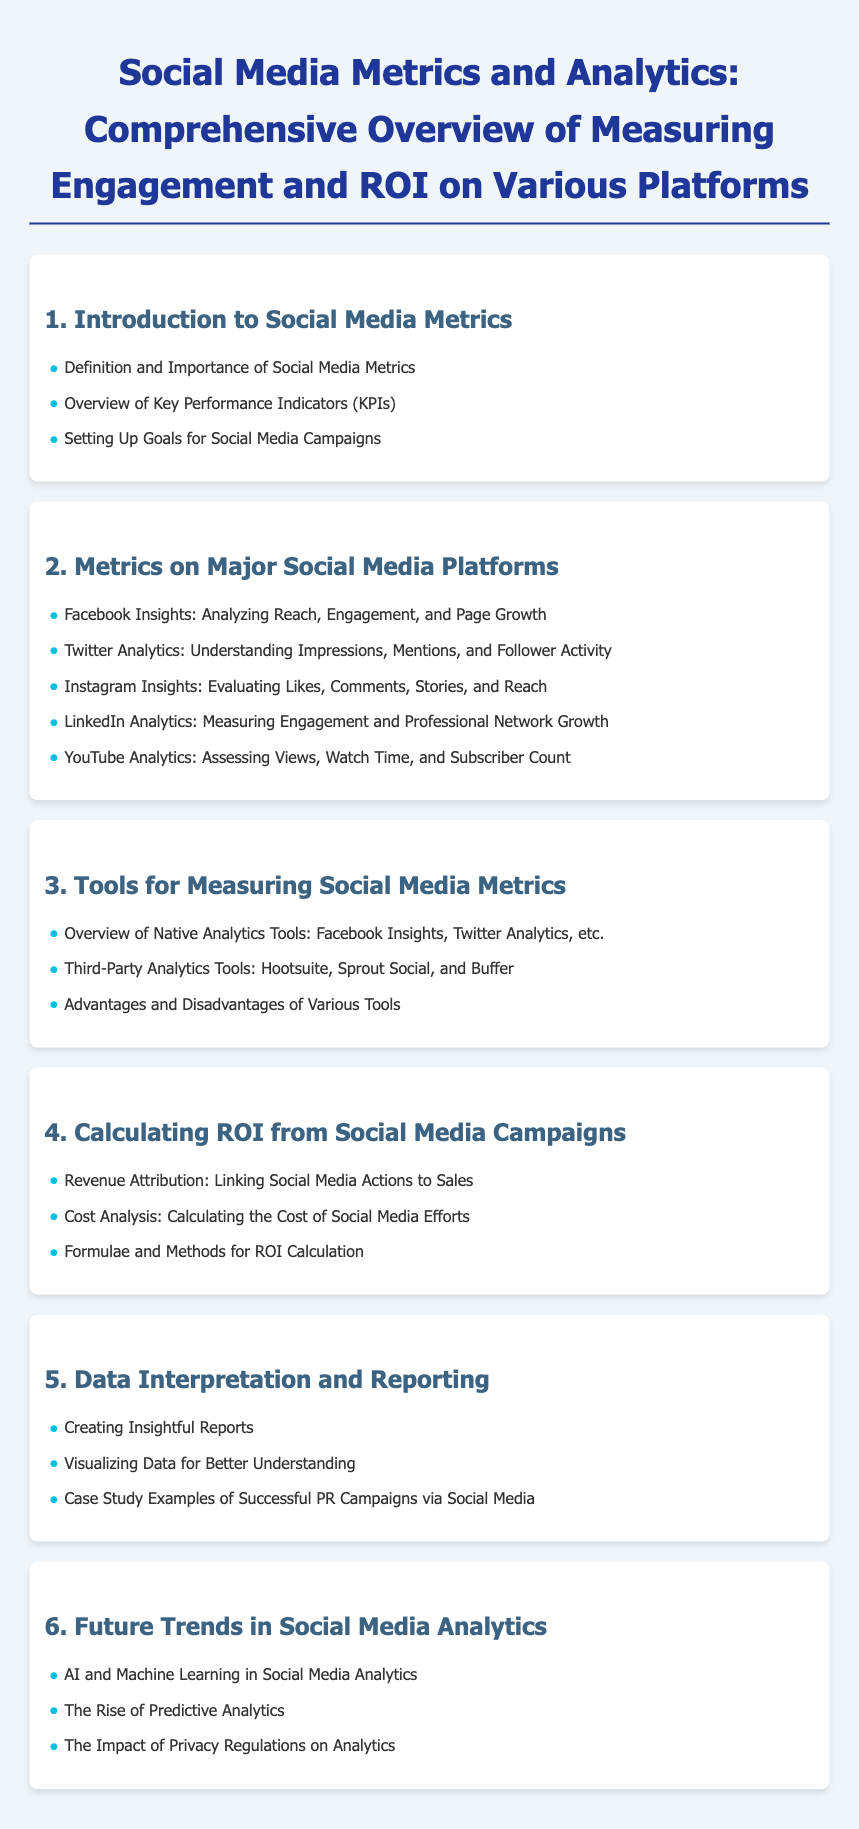what is the title of the document? The title of the document is found at the top, indicating the subject matter being discussed.
Answer: Social Media Metrics and Analytics: Comprehensive Overview of Measuring Engagement and ROI on Various Platforms how many major social media platforms are metrics discussed for? The document lists specific platforms under a certain chapter that details metrics on major social media platforms.
Answer: Five what is the first topic listed under Introduction to Social Media Metrics? The first topic indicates the foundational aspect of social media metrics and is listed in the first chapter.
Answer: Definition and Importance of Social Media Metrics which social media platform is associated with analyzing reach and engagement? This platform is mentioned specifically in the context of metrics analysis in the document.
Answer: Facebook what tools are mentioned for measuring social media metrics? The document lists specific tools that assist in measuring social media metrics and engagement.
Answer: Hootsuite, Sprout Social, and Buffer what section discusses the future of social media analytics? This section covers emerging trends and advancements in the field of social media analytics.
Answer: Future Trends in Social Media Analytics what is the focus of the fourth chapter? This chapter highlights a crucial financial aspect within social media campaigns.
Answer: Calculating ROI from Social Media Campaigns 